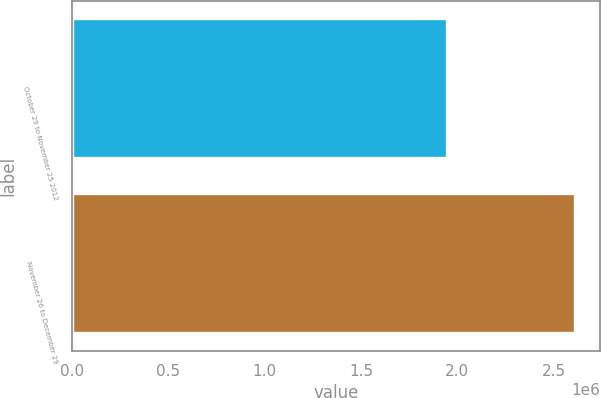Convert chart. <chart><loc_0><loc_0><loc_500><loc_500><bar_chart><fcel>October 29 to November 25 2012<fcel>November 26 to December 29<nl><fcel>1.94753e+06<fcel>2.60981e+06<nl></chart> 